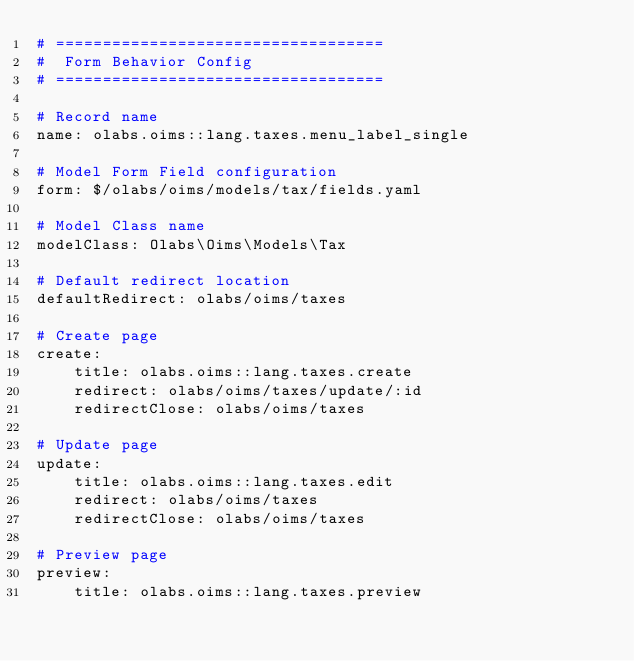<code> <loc_0><loc_0><loc_500><loc_500><_YAML_># ===================================
#  Form Behavior Config
# ===================================

# Record name
name: olabs.oims::lang.taxes.menu_label_single

# Model Form Field configuration
form: $/olabs/oims/models/tax/fields.yaml

# Model Class name
modelClass: Olabs\Oims\Models\Tax

# Default redirect location
defaultRedirect: olabs/oims/taxes

# Create page
create:
    title: olabs.oims::lang.taxes.create
    redirect: olabs/oims/taxes/update/:id
    redirectClose: olabs/oims/taxes

# Update page
update:
    title: olabs.oims::lang.taxes.edit
    redirect: olabs/oims/taxes
    redirectClose: olabs/oims/taxes

# Preview page
preview:
    title: olabs.oims::lang.taxes.preview</code> 